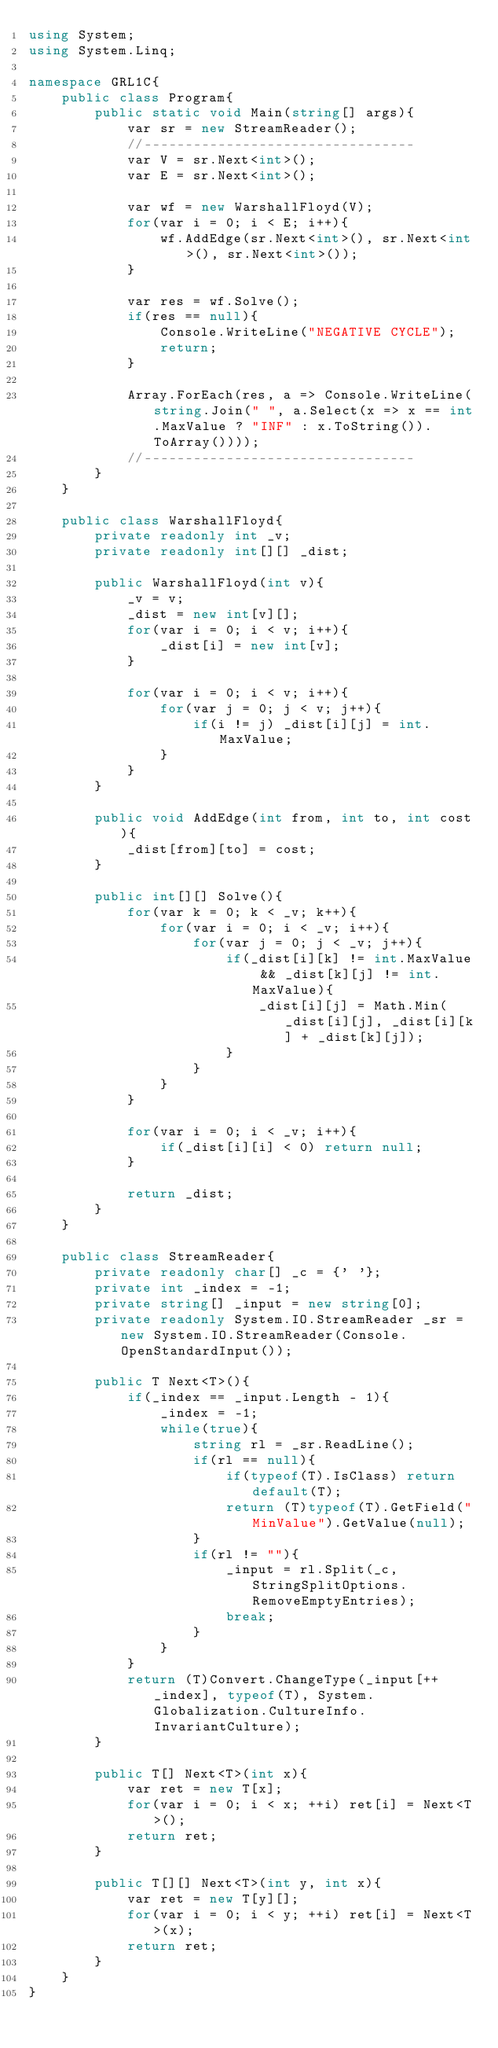Convert code to text. <code><loc_0><loc_0><loc_500><loc_500><_C#_>using System;
using System.Linq;

namespace GRL1C{
    public class Program{
        public static void Main(string[] args){
            var sr = new StreamReader();
            //---------------------------------
            var V = sr.Next<int>();
            var E = sr.Next<int>();

            var wf = new WarshallFloyd(V);
            for(var i = 0; i < E; i++){
                wf.AddEdge(sr.Next<int>(), sr.Next<int>(), sr.Next<int>());
            }

            var res = wf.Solve();
            if(res == null){
                Console.WriteLine("NEGATIVE CYCLE");
                return;
            }

            Array.ForEach(res, a => Console.WriteLine(string.Join(" ", a.Select(x => x == int.MaxValue ? "INF" : x.ToString()).ToArray())));
            //---------------------------------
        }
    }

    public class WarshallFloyd{
        private readonly int _v;
        private readonly int[][] _dist;

        public WarshallFloyd(int v){
            _v = v;
            _dist = new int[v][];
            for(var i = 0; i < v; i++){
                _dist[i] = new int[v];
            }

            for(var i = 0; i < v; i++){
                for(var j = 0; j < v; j++){
                    if(i != j) _dist[i][j] = int.MaxValue;
                }
            }
        }

        public void AddEdge(int from, int to, int cost){
            _dist[from][to] = cost;
        }

        public int[][] Solve(){
            for(var k = 0; k < _v; k++){
                for(var i = 0; i < _v; i++){
                    for(var j = 0; j < _v; j++){
                        if(_dist[i][k] != int.MaxValue && _dist[k][j] != int.MaxValue){
                            _dist[i][j] = Math.Min(_dist[i][j], _dist[i][k] + _dist[k][j]);
                        }
                    }
                }
            }

            for(var i = 0; i < _v; i++){
                if(_dist[i][i] < 0) return null;
            }

            return _dist;
        }
    }
   
    public class StreamReader{
        private readonly char[] _c = {' '};
        private int _index = -1;
        private string[] _input = new string[0];
        private readonly System.IO.StreamReader _sr = new System.IO.StreamReader(Console.OpenStandardInput());

        public T Next<T>(){
            if(_index == _input.Length - 1){
                _index = -1;
                while(true){
                    string rl = _sr.ReadLine();
                    if(rl == null){
                        if(typeof(T).IsClass) return default(T);
                        return (T)typeof(T).GetField("MinValue").GetValue(null);
                    }
                    if(rl != ""){
                        _input = rl.Split(_c, StringSplitOptions.RemoveEmptyEntries);
                        break;
                    }
                }
            }
            return (T)Convert.ChangeType(_input[++_index], typeof(T), System.Globalization.CultureInfo.InvariantCulture);
        }

        public T[] Next<T>(int x){
            var ret = new T[x];
            for(var i = 0; i < x; ++i) ret[i] = Next<T>();
            return ret;
        }

        public T[][] Next<T>(int y, int x){
            var ret = new T[y][];
            for(var i = 0; i < y; ++i) ret[i] = Next<T>(x);
            return ret;
        }
    }
}</code> 